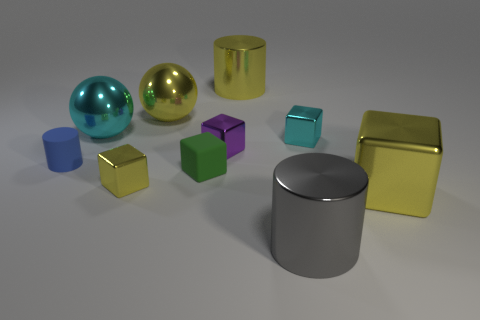Are there any reflections that suggest the lighting direction? Yes, the placement and intensity of reflections on the objects suggest that the primary light source is coming from the upper left side of the image. Is this lighting creating any noticeable shadows? The lighting creates soft-edged shadows to the right of the objects, consistent with a diffuse light source, softening the overall look of the scene. 